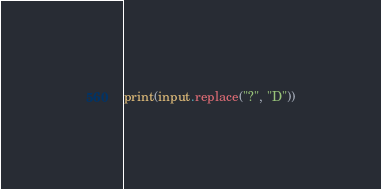<code> <loc_0><loc_0><loc_500><loc_500><_Python_>print(input.replace("?", "D"))</code> 